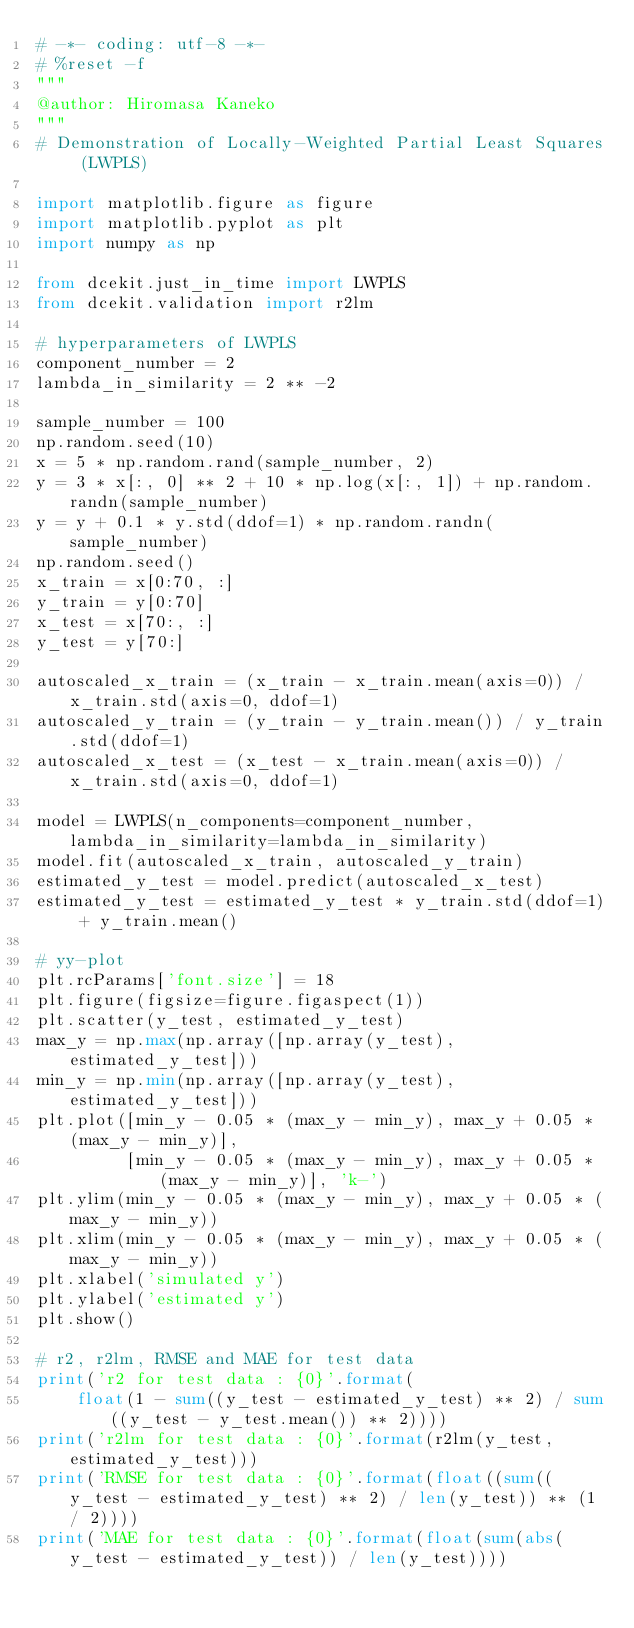<code> <loc_0><loc_0><loc_500><loc_500><_Python_># -*- coding: utf-8 -*- 
# %reset -f
"""
@author: Hiromasa Kaneko
"""
# Demonstration of Locally-Weighted Partial Least Squares (LWPLS)

import matplotlib.figure as figure
import matplotlib.pyplot as plt
import numpy as np

from dcekit.just_in_time import LWPLS
from dcekit.validation import r2lm

# hyperparameters of LWPLS
component_number = 2
lambda_in_similarity = 2 ** -2

sample_number = 100
np.random.seed(10)
x = 5 * np.random.rand(sample_number, 2)
y = 3 * x[:, 0] ** 2 + 10 * np.log(x[:, 1]) + np.random.randn(sample_number)
y = y + 0.1 * y.std(ddof=1) * np.random.randn(sample_number)
np.random.seed()
x_train = x[0:70, :]
y_train = y[0:70]
x_test = x[70:, :]
y_test = y[70:]

autoscaled_x_train = (x_train - x_train.mean(axis=0)) / x_train.std(axis=0, ddof=1)
autoscaled_y_train = (y_train - y_train.mean()) / y_train.std(ddof=1)
autoscaled_x_test = (x_test - x_train.mean(axis=0)) / x_train.std(axis=0, ddof=1)

model = LWPLS(n_components=component_number, lambda_in_similarity=lambda_in_similarity)
model.fit(autoscaled_x_train, autoscaled_y_train)
estimated_y_test = model.predict(autoscaled_x_test)
estimated_y_test = estimated_y_test * y_train.std(ddof=1) + y_train.mean()

# yy-plot
plt.rcParams['font.size'] = 18
plt.figure(figsize=figure.figaspect(1))
plt.scatter(y_test, estimated_y_test)
max_y = np.max(np.array([np.array(y_test), estimated_y_test]))
min_y = np.min(np.array([np.array(y_test), estimated_y_test]))
plt.plot([min_y - 0.05 * (max_y - min_y), max_y + 0.05 * (max_y - min_y)],
         [min_y - 0.05 * (max_y - min_y), max_y + 0.05 * (max_y - min_y)], 'k-')
plt.ylim(min_y - 0.05 * (max_y - min_y), max_y + 0.05 * (max_y - min_y))
plt.xlim(min_y - 0.05 * (max_y - min_y), max_y + 0.05 * (max_y - min_y))
plt.xlabel('simulated y')
plt.ylabel('estimated y')
plt.show()

# r2, r2lm, RMSE and MAE for test data
print('r2 for test data : {0}'.format(
    float(1 - sum((y_test - estimated_y_test) ** 2) / sum((y_test - y_test.mean()) ** 2))))
print('r2lm for test data : {0}'.format(r2lm(y_test, estimated_y_test)))
print('RMSE for test data : {0}'.format(float((sum((y_test - estimated_y_test) ** 2) / len(y_test)) ** (1 / 2))))
print('MAE for test data : {0}'.format(float(sum(abs(y_test - estimated_y_test)) / len(y_test))))
</code> 